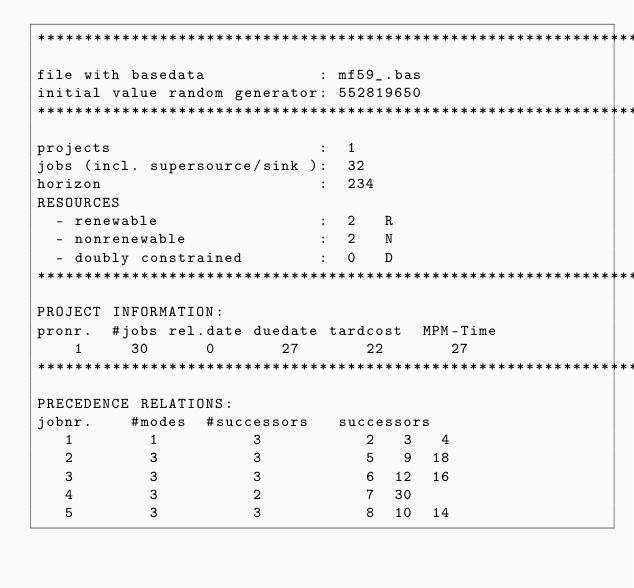Convert code to text. <code><loc_0><loc_0><loc_500><loc_500><_ObjectiveC_>************************************************************************
file with basedata            : mf59_.bas
initial value random generator: 552819650
************************************************************************
projects                      :  1
jobs (incl. supersource/sink ):  32
horizon                       :  234
RESOURCES
  - renewable                 :  2   R
  - nonrenewable              :  2   N
  - doubly constrained        :  0   D
************************************************************************
PROJECT INFORMATION:
pronr.  #jobs rel.date duedate tardcost  MPM-Time
    1     30      0       27       22       27
************************************************************************
PRECEDENCE RELATIONS:
jobnr.    #modes  #successors   successors
   1        1          3           2   3   4
   2        3          3           5   9  18
   3        3          3           6  12  16
   4        3          2           7  30
   5        3          3           8  10  14</code> 